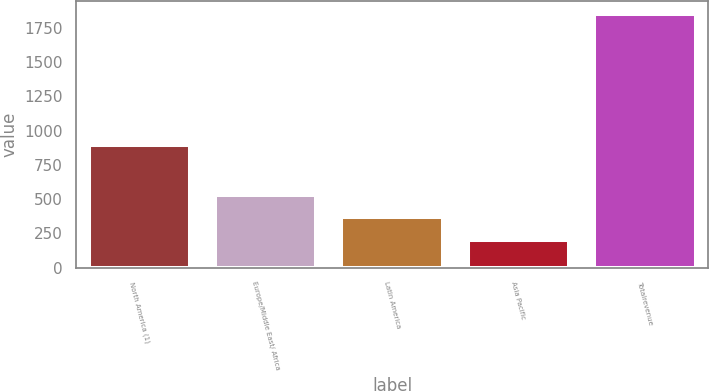Convert chart to OTSL. <chart><loc_0><loc_0><loc_500><loc_500><bar_chart><fcel>North America (1)<fcel>Europe/Middle East/ Africa<fcel>Latin America<fcel>Asia Pacific<fcel>Totalrevenue<nl><fcel>895.2<fcel>533.7<fcel>368.8<fcel>203.9<fcel>1852.9<nl></chart> 